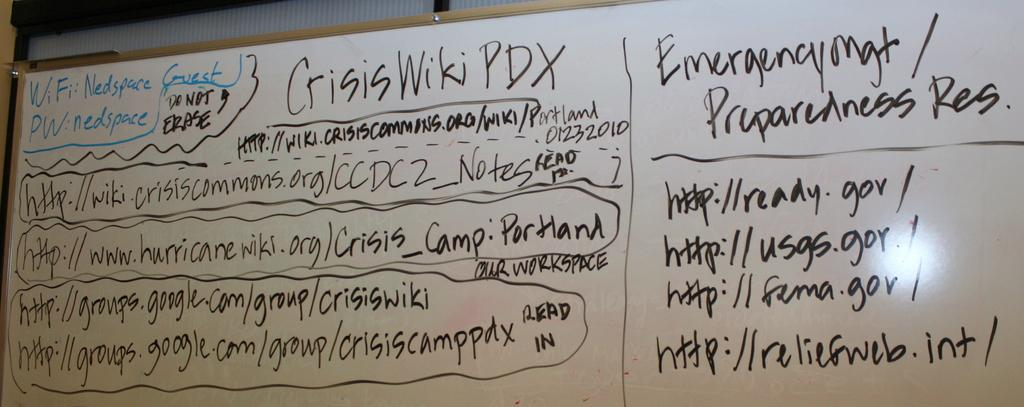<image>
Write a terse but informative summary of the picture. Several websites are written for Emergency Mgt Preparedness Resolution. 